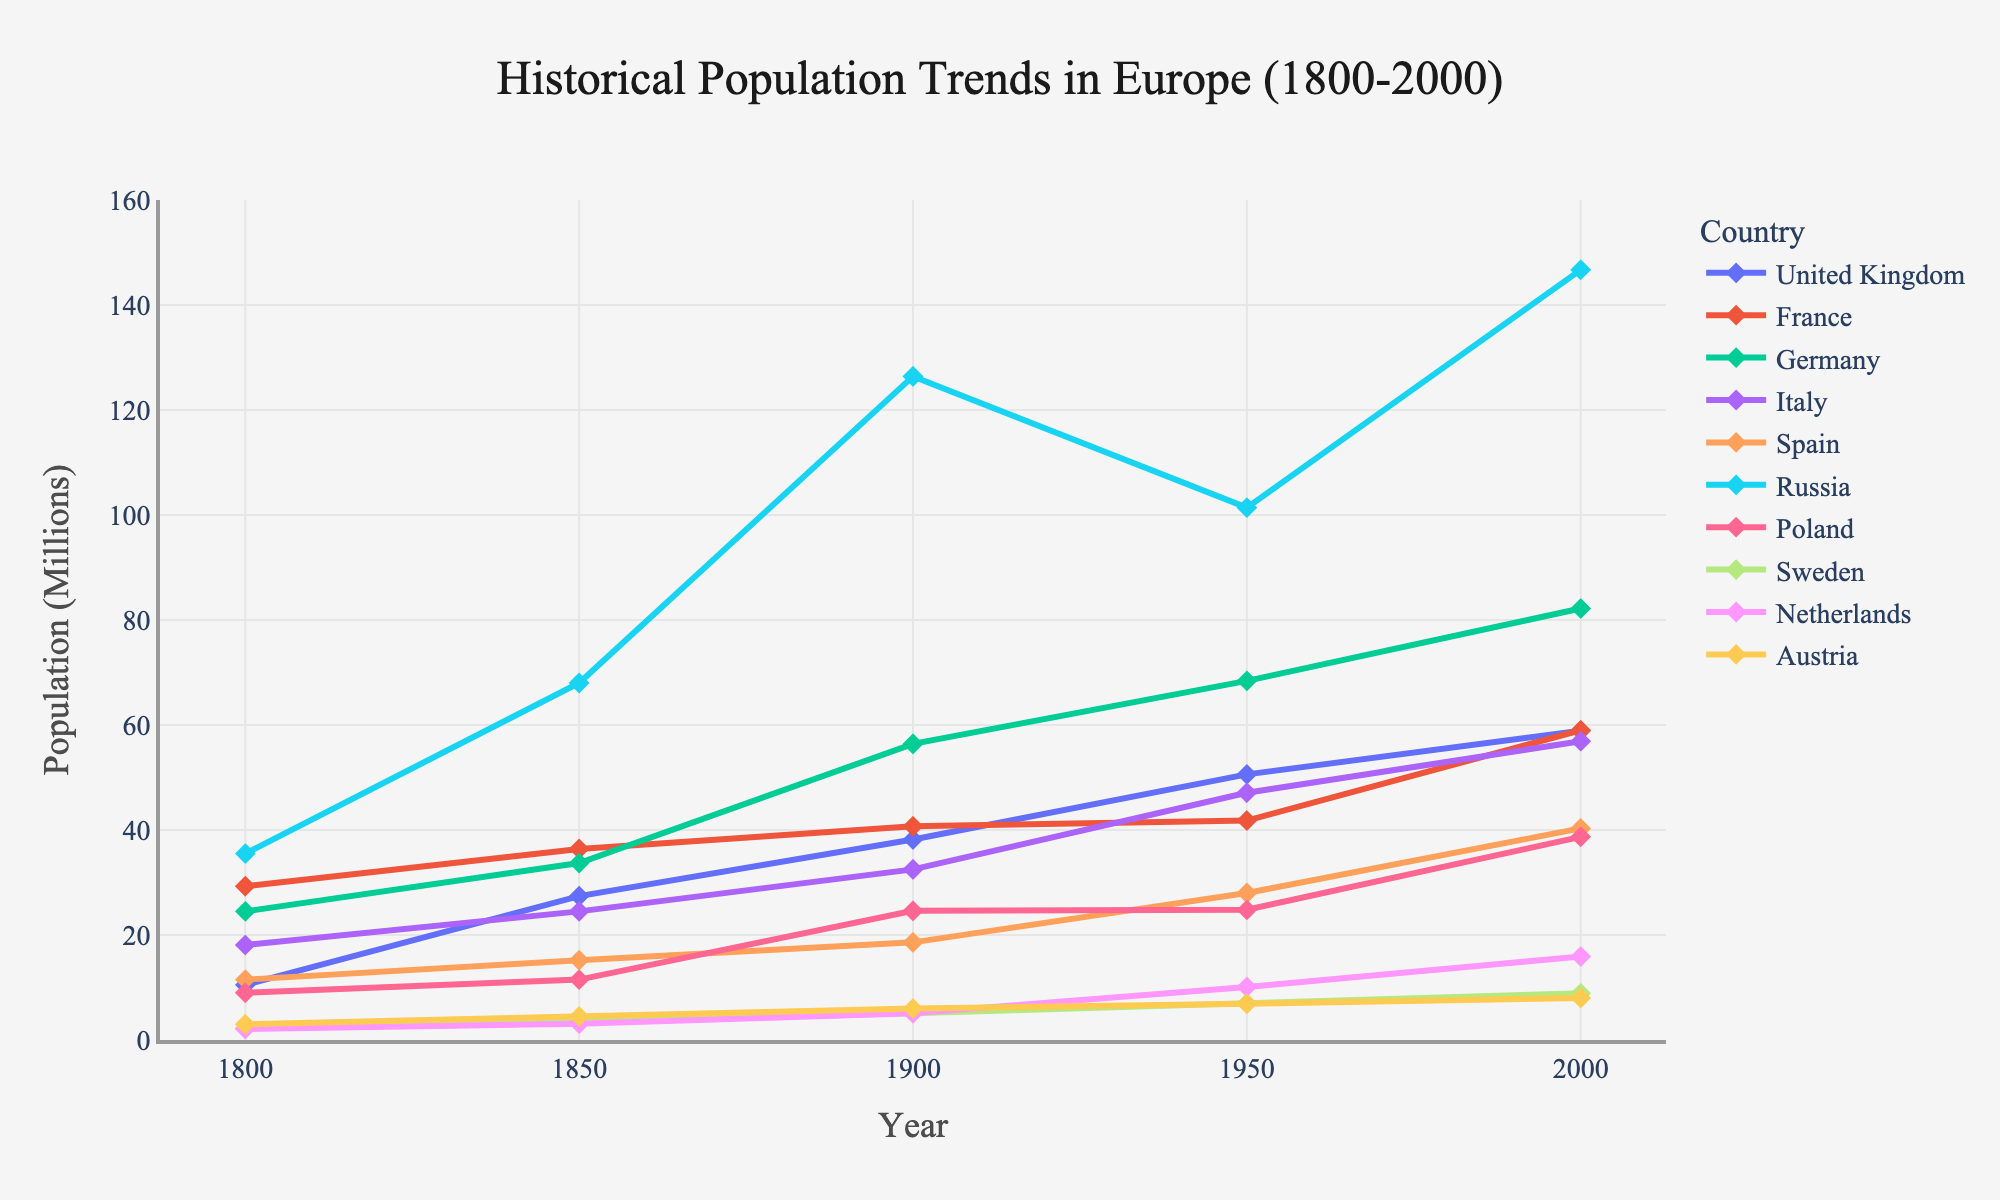Which country had the highest population in 2000? From the chart, the population in 2000 for Russia is the highest, significantly more than all other countries.
Answer: Russia Which two countries had the closest populations in 1800? By observing the height of the lines corresponding to 1800, both Austria and Netherlands have closely related populations, but Austria has a population (3.0 million) that is slightly higher than Netherlands (2.1 million); however, they are not the closest. Poland and United Kingdom both exhibit populations close in value approximately 9.0 versus 10.5 million.
Answer: Poland, United Kingdom Was Germany's population growth linear or exponential from 1800 to 2000? By following Germany's population curve, we can see that its population growth wasn't linear and shows more exponential characteristics, particularly noticeable around the 1850 to 1900 period and again from 1950 to 2000.
Answer: Exponential Which country experienced a decline in population around 1950? The chart shows that Russia experienced a significant decrease in its population from 126.4 million in 1900 to 101.4 million in 1950.
Answer: Russia Which countries' populations were lower than 10 million in 1900? From the chart data for the year 1900, the populations of Sweden (5.1 million) and Austria (6.0 million) are the only countries below 10 million.
Answer: Sweden, Austria Compare the population growth trends of France and Italy from 1800 to 2000. Which country had a faster population growth rate? By looking at the line slopes and their increments on the chart for both countries, Italy's population growth shows a steeper and more consistent increase compared to France, indicating a faster growth rate.
Answer: Italy What's the total population of United Kingdom and France in 1850? From the chart, the population of the United Kingdom in 1850 is 27.4 million and France is 36.4 million. Adding these values gives the total population: 27.4 + 36.4 = 63.8 million.
Answer: 63.8 million Which country shows the least population growth over the 200 years? From the chart, Austria shows the least population growth, starting at 3.0 million in 1800 and ending at 8.0 million in 2000.
Answer: Austria 